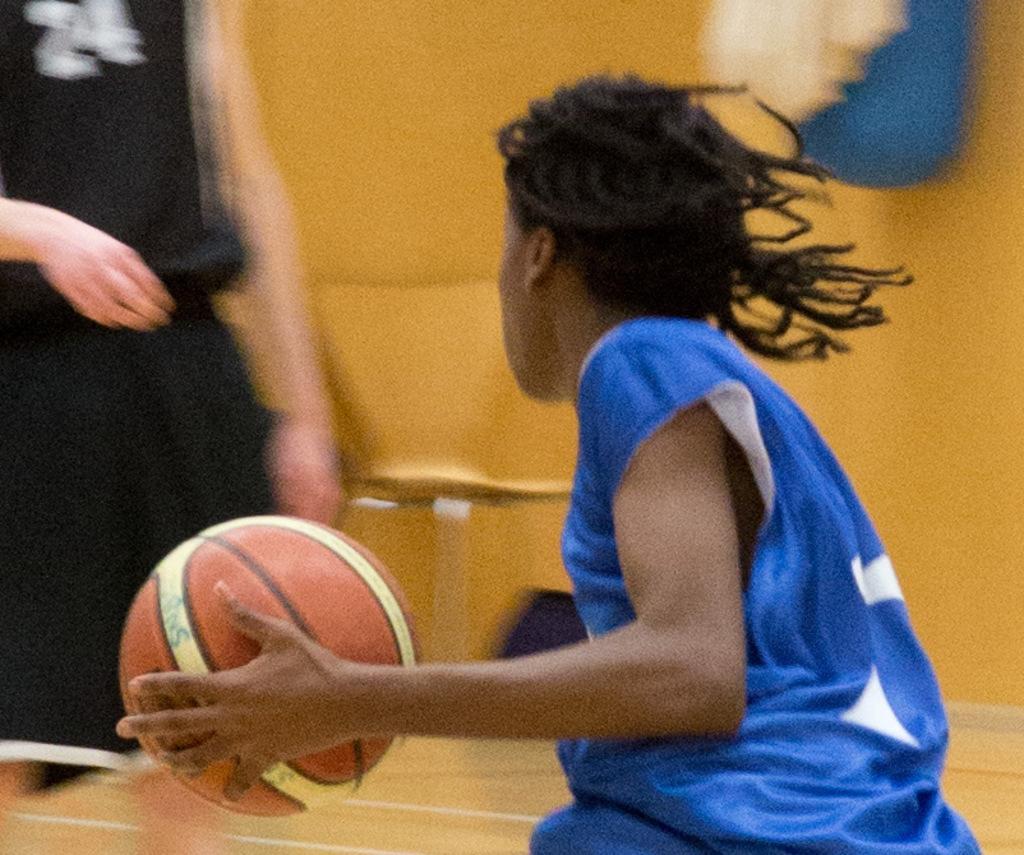How would you summarize this image in a sentence or two? This picture describes about few people, in the middle of the image we can see a person, and the person is holding a ball. 